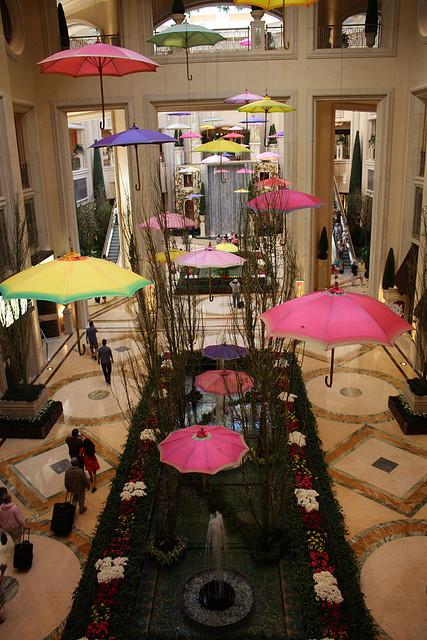Where are the umbrellas?
Concise answer only. Hanging from ceiling. How many umbrellas are there?
Be succinct. 14. Is there a green umbrella in the picture?
Answer briefly. No. 